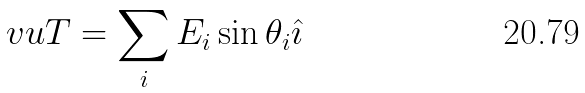Convert formula to latex. <formula><loc_0><loc_0><loc_500><loc_500>\ v u T = \sum _ { i } E _ { i } \sin \theta _ { i } \hat { \imath }</formula> 